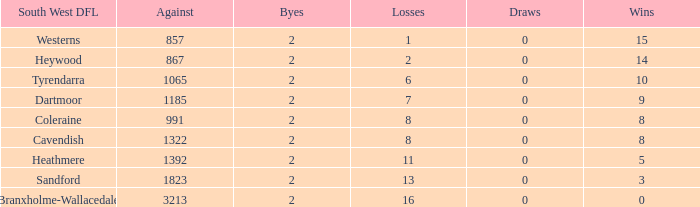How many successes have 16 setbacks and an against smaller than 3213? None. Parse the full table. {'header': ['South West DFL', 'Against', 'Byes', 'Losses', 'Draws', 'Wins'], 'rows': [['Westerns', '857', '2', '1', '0', '15'], ['Heywood', '867', '2', '2', '0', '14'], ['Tyrendarra', '1065', '2', '6', '0', '10'], ['Dartmoor', '1185', '2', '7', '0', '9'], ['Coleraine', '991', '2', '8', '0', '8'], ['Cavendish', '1322', '2', '8', '0', '8'], ['Heathmere', '1392', '2', '11', '0', '5'], ['Sandford', '1823', '2', '13', '0', '3'], ['Branxholme-Wallacedale', '3213', '2', '16', '0', '0']]} 